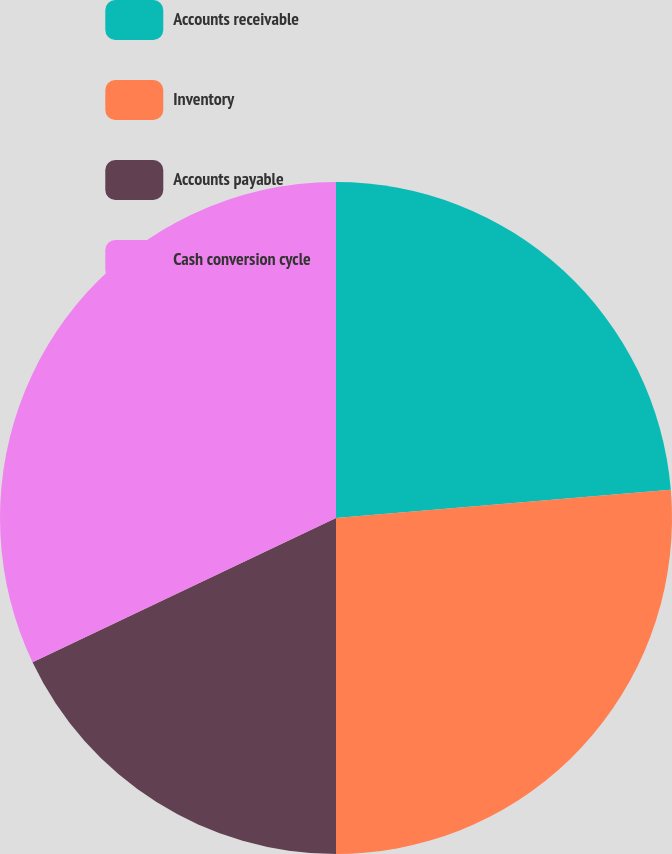<chart> <loc_0><loc_0><loc_500><loc_500><pie_chart><fcel>Accounts receivable<fcel>Inventory<fcel>Accounts payable<fcel>Cash conversion cycle<nl><fcel>23.66%<fcel>26.34%<fcel>17.94%<fcel>32.06%<nl></chart> 